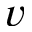<formula> <loc_0><loc_0><loc_500><loc_500>v</formula> 